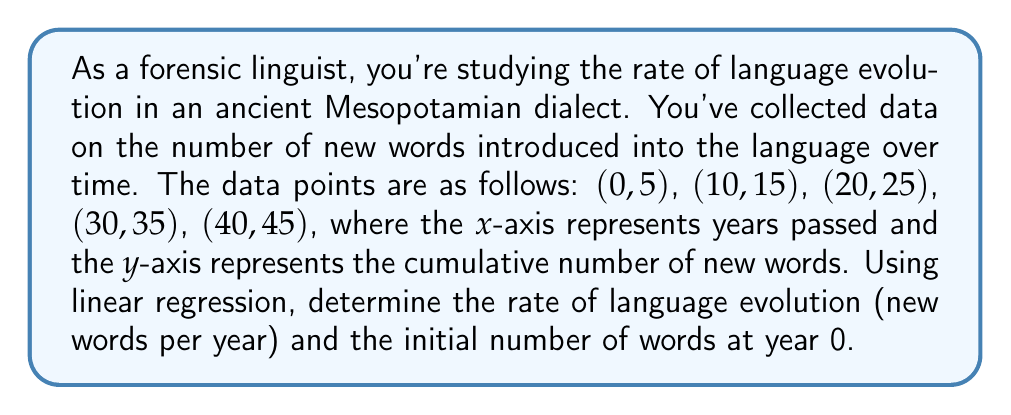Help me with this question. To solve this problem using linear regression, we'll follow these steps:

1. Calculate the means of x and y:
   $\bar{x} = \frac{0 + 10 + 20 + 30 + 40}{5} = 20$
   $\bar{y} = \frac{5 + 15 + 25 + 35 + 45}{5} = 25$

2. Calculate the slope (m) using the formula:
   $$m = \frac{\sum(x_i - \bar{x})(y_i - \bar{y})}{\sum(x_i - \bar{x})^2}$$

   $(x_i - \bar{x})(y_i - \bar{y})$: $(-20)(-20) + (-10)(-10) + (0)(0) + (10)(10) + (20)(20) = 1000$
   $(x_i - \bar{x})^2$: $(-20)^2 + (-10)^2 + (0)^2 + (10)^2 + (20)^2 = 1000$

   $m = \frac{1000}{1000} = 1$

3. Calculate the y-intercept (b) using the formula:
   $$b = \bar{y} - m\bar{x}$$
   $b = 25 - 1(20) = 5$

4. The linear regression equation is:
   $$y = mx + b$$
   $$y = 1x + 5$$

Therefore, the rate of language evolution is 1 new word per year (the slope), and the initial number of words at year 0 is 5 (the y-intercept).
Answer: Rate: 1 word/year; Initial words: 5 